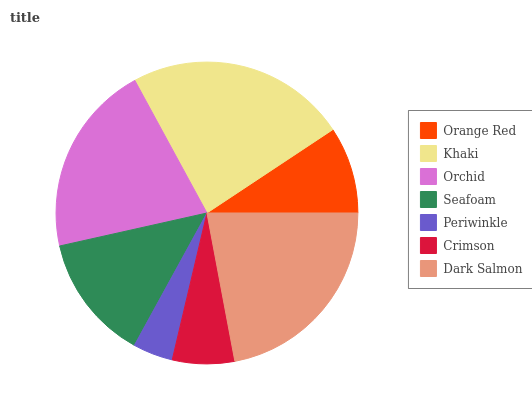Is Periwinkle the minimum?
Answer yes or no. Yes. Is Khaki the maximum?
Answer yes or no. Yes. Is Orchid the minimum?
Answer yes or no. No. Is Orchid the maximum?
Answer yes or no. No. Is Khaki greater than Orchid?
Answer yes or no. Yes. Is Orchid less than Khaki?
Answer yes or no. Yes. Is Orchid greater than Khaki?
Answer yes or no. No. Is Khaki less than Orchid?
Answer yes or no. No. Is Seafoam the high median?
Answer yes or no. Yes. Is Seafoam the low median?
Answer yes or no. Yes. Is Periwinkle the high median?
Answer yes or no. No. Is Khaki the low median?
Answer yes or no. No. 